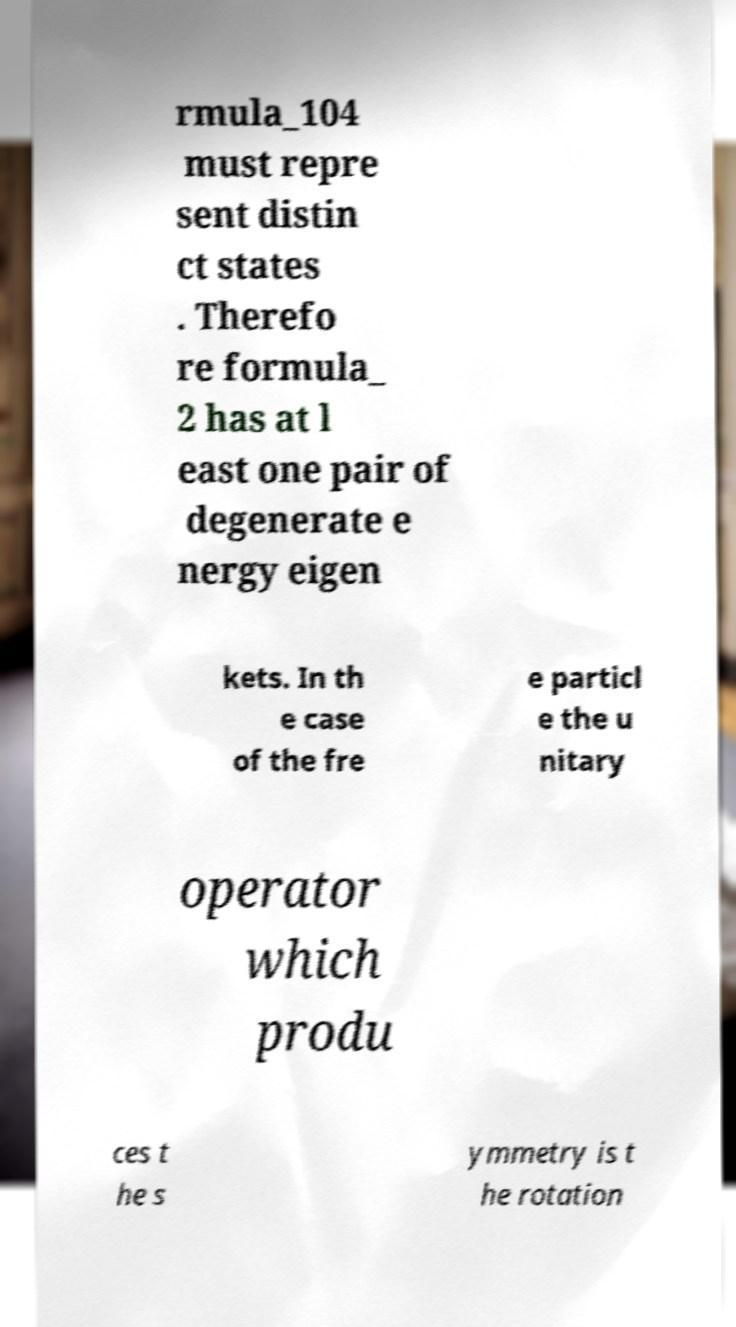For documentation purposes, I need the text within this image transcribed. Could you provide that? rmula_104 must repre sent distin ct states . Therefo re formula_ 2 has at l east one pair of degenerate e nergy eigen kets. In th e case of the fre e particl e the u nitary operator which produ ces t he s ymmetry is t he rotation 